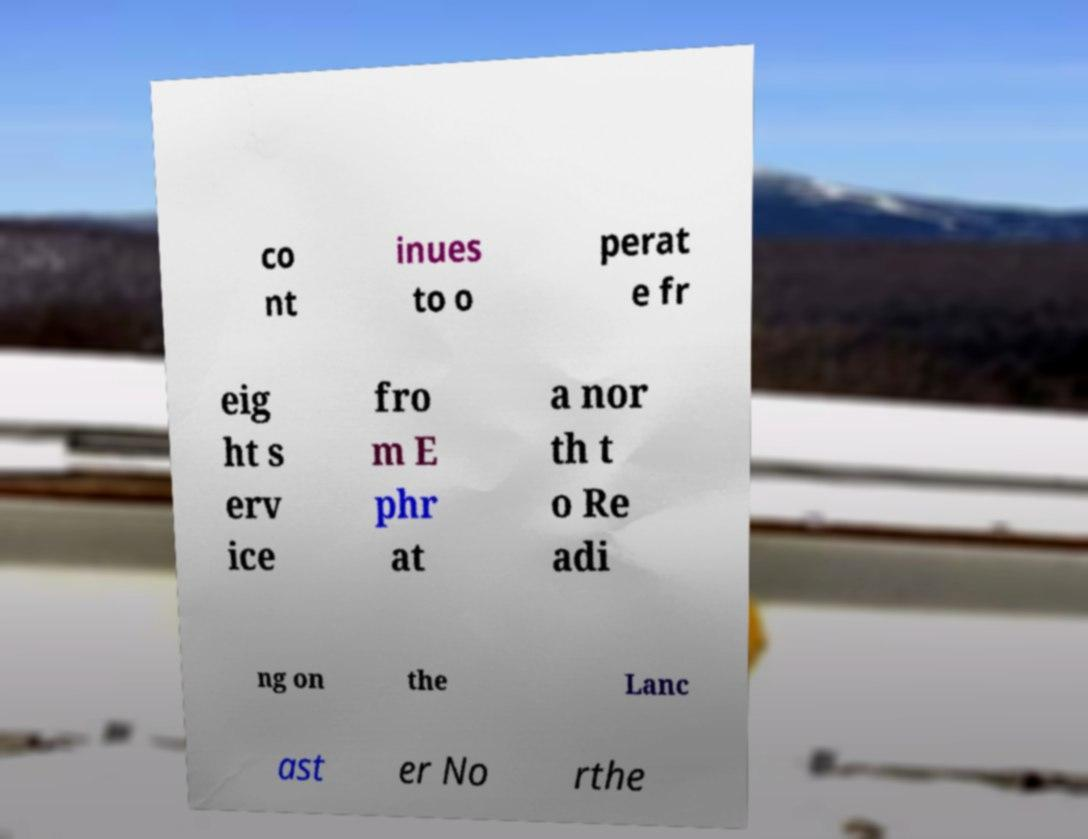Can you accurately transcribe the text from the provided image for me? co nt inues to o perat e fr eig ht s erv ice fro m E phr at a nor th t o Re adi ng on the Lanc ast er No rthe 